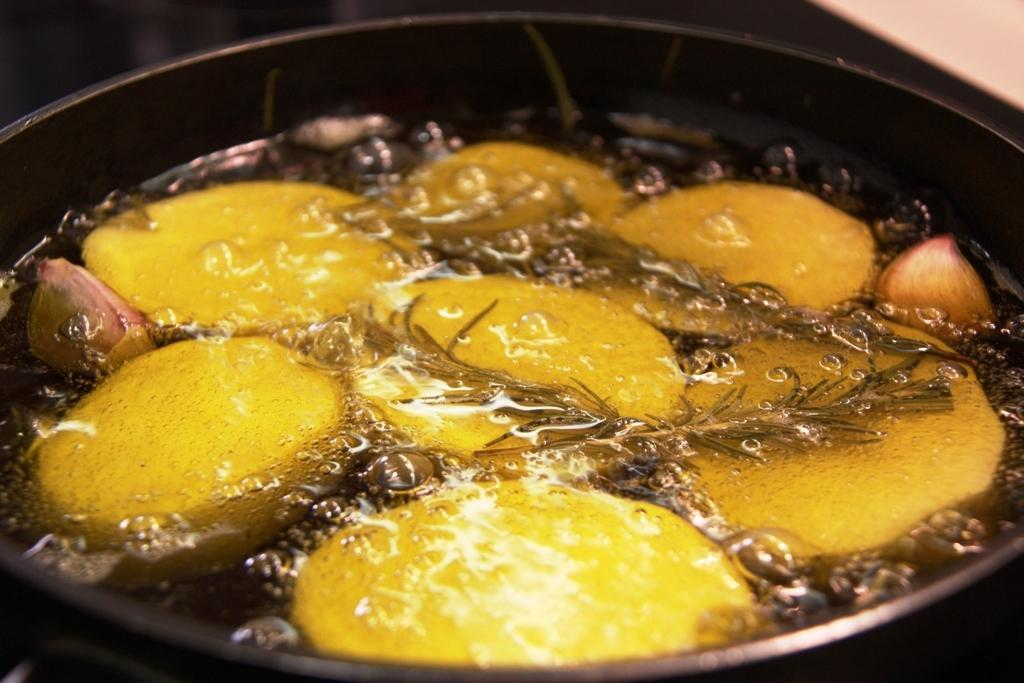What type of food items can be seen in the image? There are vegetables and herbs in the image. How are the vegetables and herbs being prepared? The vegetables and herbs are boiling in water. What is the water contained in? The water is in a pan. What nation is represented by the vegetables and herbs in the image? The image does not represent any specific nation; it simply shows vegetables and herbs being boiled in water. What type of apparatus is used to walk on the vegetables and herbs in the image? There is no apparatus or walking involved in the image; it only shows vegetables and herbs being boiled in water. 